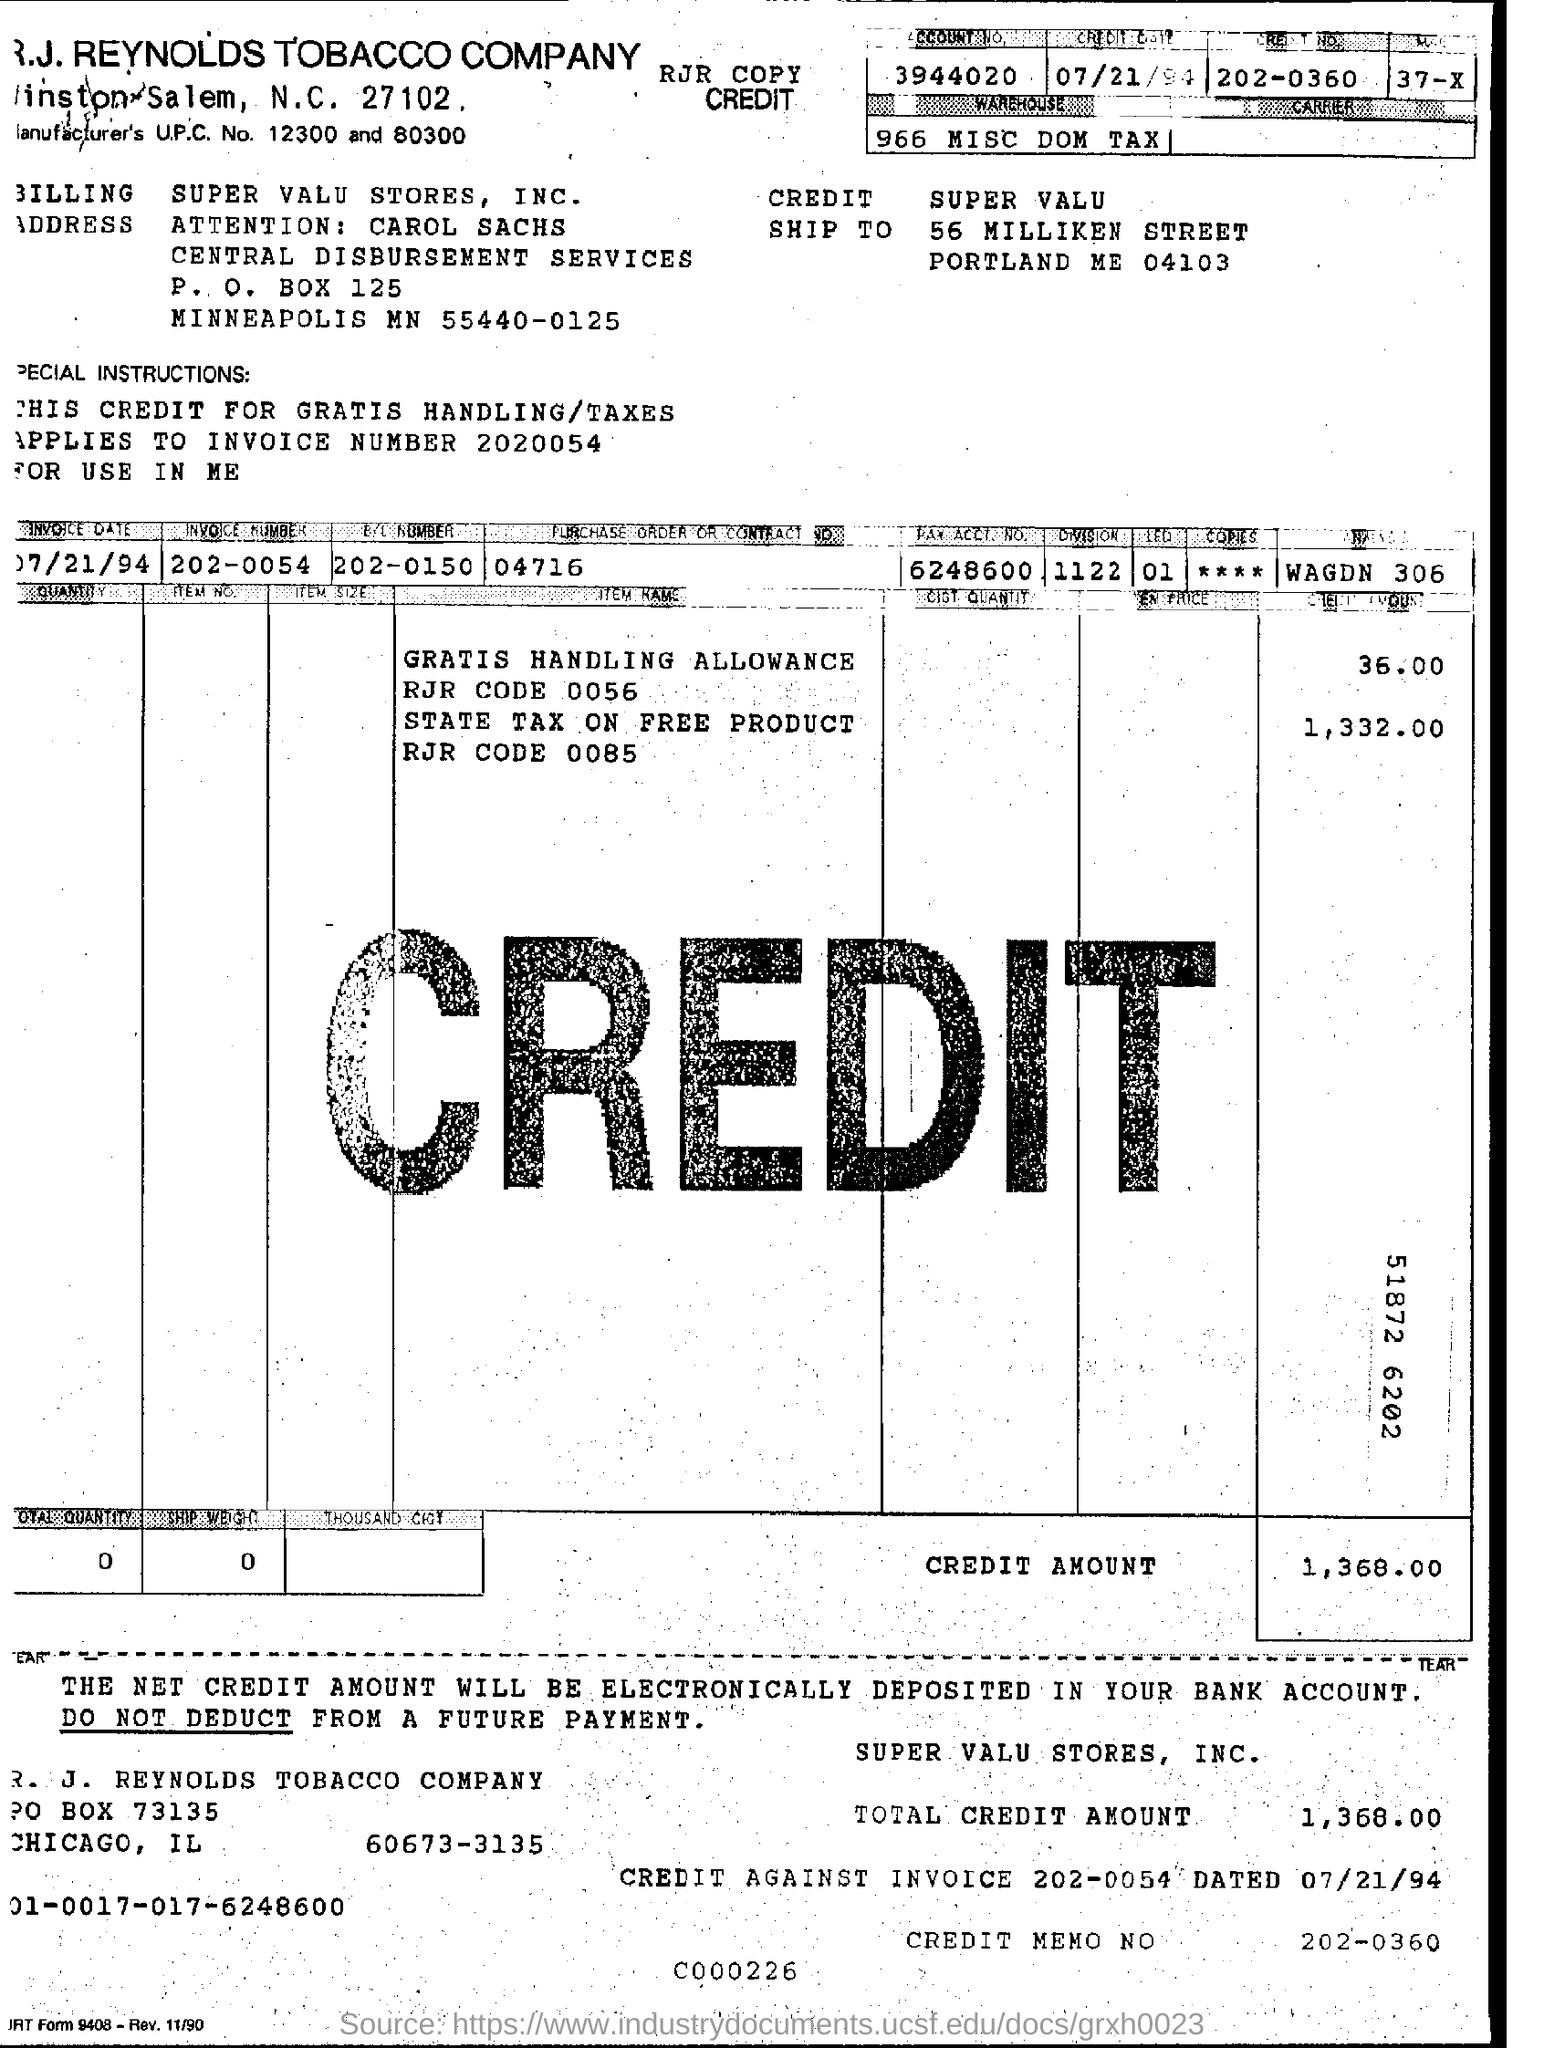What is the Company Name ?
Your response must be concise. R.J. REYNOLDS TOBACCO COMPANY. What is the P.O Box Number of top of the document ?
Your answer should be very brief. 125. What is the total Credit Amount?
Offer a very short reply. 1,368.00. What is the Credit Memo Number ?
Keep it short and to the point. 202-0360. 